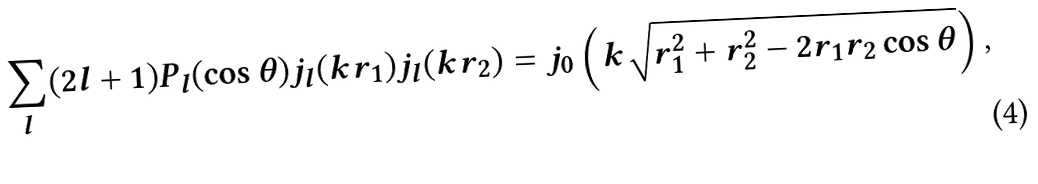<formula> <loc_0><loc_0><loc_500><loc_500>\sum _ { l } ( 2 l + 1 ) P _ { l } ( \cos \theta ) j _ { l } ( k r _ { 1 } ) j _ { l } ( k r _ { 2 } ) = j _ { 0 } \left ( k \sqrt { r _ { 1 } ^ { 2 } + r _ { 2 } ^ { 2 } - 2 r _ { 1 } r _ { 2 } \cos \theta } \right ) ,</formula> 